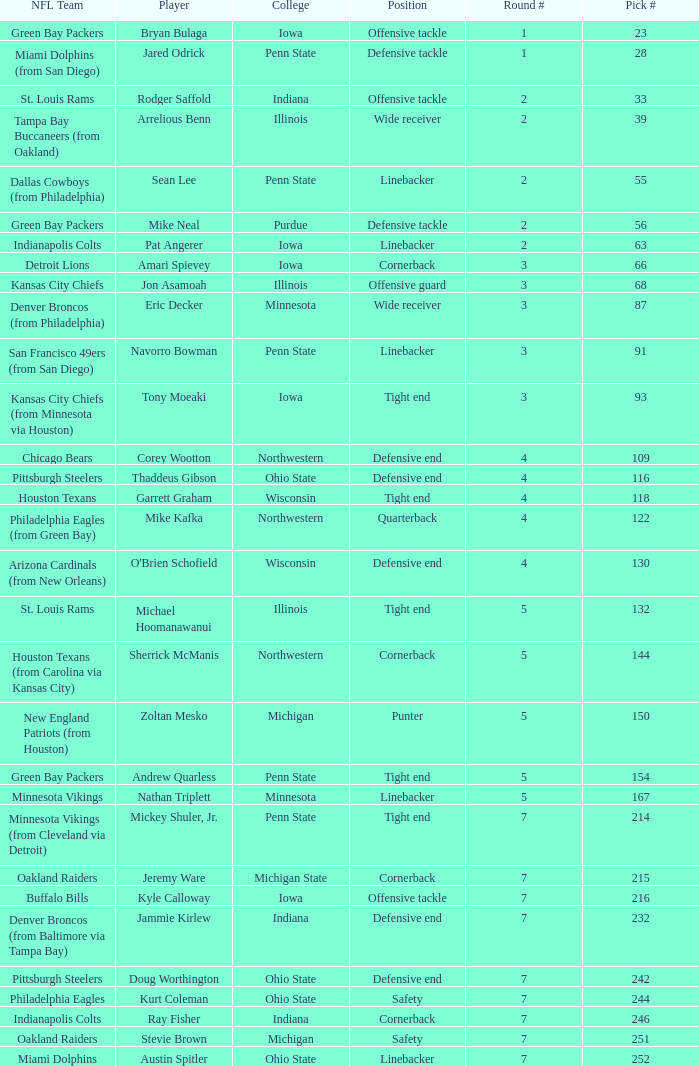What NFL team was the player with pick number 28 drafted to? Miami Dolphins (from San Diego). 